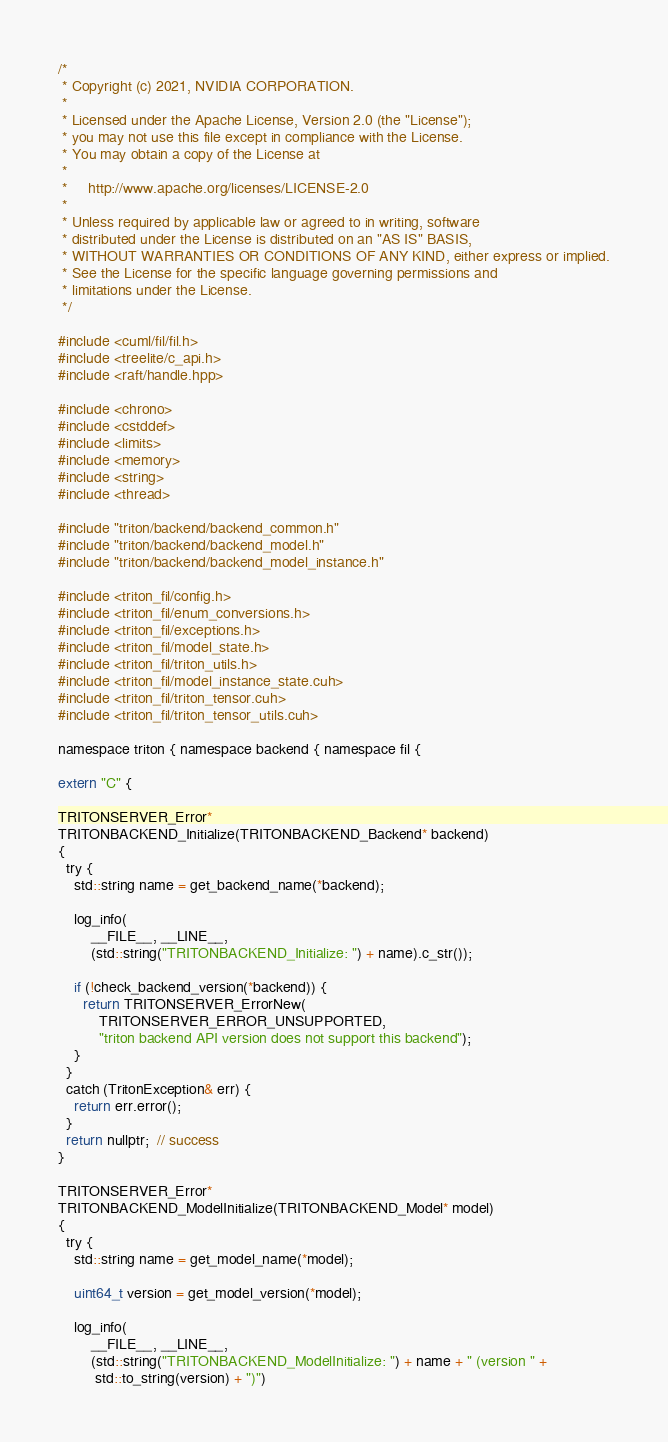<code> <loc_0><loc_0><loc_500><loc_500><_Cuda_>/*
 * Copyright (c) 2021, NVIDIA CORPORATION.
 *
 * Licensed under the Apache License, Version 2.0 (the "License");
 * you may not use this file except in compliance with the License.
 * You may obtain a copy of the License at
 *
 *     http://www.apache.org/licenses/LICENSE-2.0
 *
 * Unless required by applicable law or agreed to in writing, software
 * distributed under the License is distributed on an "AS IS" BASIS,
 * WITHOUT WARRANTIES OR CONDITIONS OF ANY KIND, either express or implied.
 * See the License for the specific language governing permissions and
 * limitations under the License.
 */

#include <cuml/fil/fil.h>
#include <treelite/c_api.h>
#include <raft/handle.hpp>

#include <chrono>
#include <cstddef>
#include <limits>
#include <memory>
#include <string>
#include <thread>

#include "triton/backend/backend_common.h"
#include "triton/backend/backend_model.h"
#include "triton/backend/backend_model_instance.h"

#include <triton_fil/config.h>
#include <triton_fil/enum_conversions.h>
#include <triton_fil/exceptions.h>
#include <triton_fil/model_state.h>
#include <triton_fil/triton_utils.h>
#include <triton_fil/model_instance_state.cuh>
#include <triton_fil/triton_tensor.cuh>
#include <triton_fil/triton_tensor_utils.cuh>

namespace triton { namespace backend { namespace fil {

extern "C" {

TRITONSERVER_Error*
TRITONBACKEND_Initialize(TRITONBACKEND_Backend* backend)
{
  try {
    std::string name = get_backend_name(*backend);

    log_info(
        __FILE__, __LINE__,
        (std::string("TRITONBACKEND_Initialize: ") + name).c_str());

    if (!check_backend_version(*backend)) {
      return TRITONSERVER_ErrorNew(
          TRITONSERVER_ERROR_UNSUPPORTED,
          "triton backend API version does not support this backend");
    }
  }
  catch (TritonException& err) {
    return err.error();
  }
  return nullptr;  // success
}

TRITONSERVER_Error*
TRITONBACKEND_ModelInitialize(TRITONBACKEND_Model* model)
{
  try {
    std::string name = get_model_name(*model);

    uint64_t version = get_model_version(*model);

    log_info(
        __FILE__, __LINE__,
        (std::string("TRITONBACKEND_ModelInitialize: ") + name + " (version " +
         std::to_string(version) + ")")</code> 